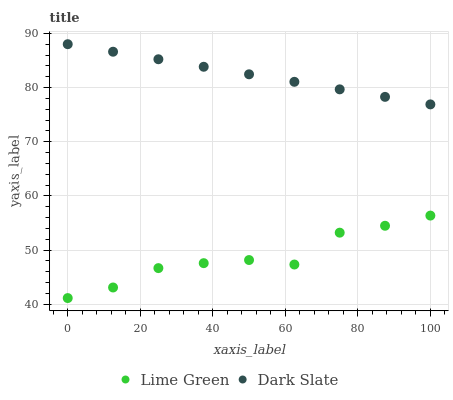Does Lime Green have the minimum area under the curve?
Answer yes or no. Yes. Does Dark Slate have the maximum area under the curve?
Answer yes or no. Yes. Does Lime Green have the maximum area under the curve?
Answer yes or no. No. Is Dark Slate the smoothest?
Answer yes or no. Yes. Is Lime Green the roughest?
Answer yes or no. Yes. Is Lime Green the smoothest?
Answer yes or no. No. Does Lime Green have the lowest value?
Answer yes or no. Yes. Does Dark Slate have the highest value?
Answer yes or no. Yes. Does Lime Green have the highest value?
Answer yes or no. No. Is Lime Green less than Dark Slate?
Answer yes or no. Yes. Is Dark Slate greater than Lime Green?
Answer yes or no. Yes. Does Lime Green intersect Dark Slate?
Answer yes or no. No. 